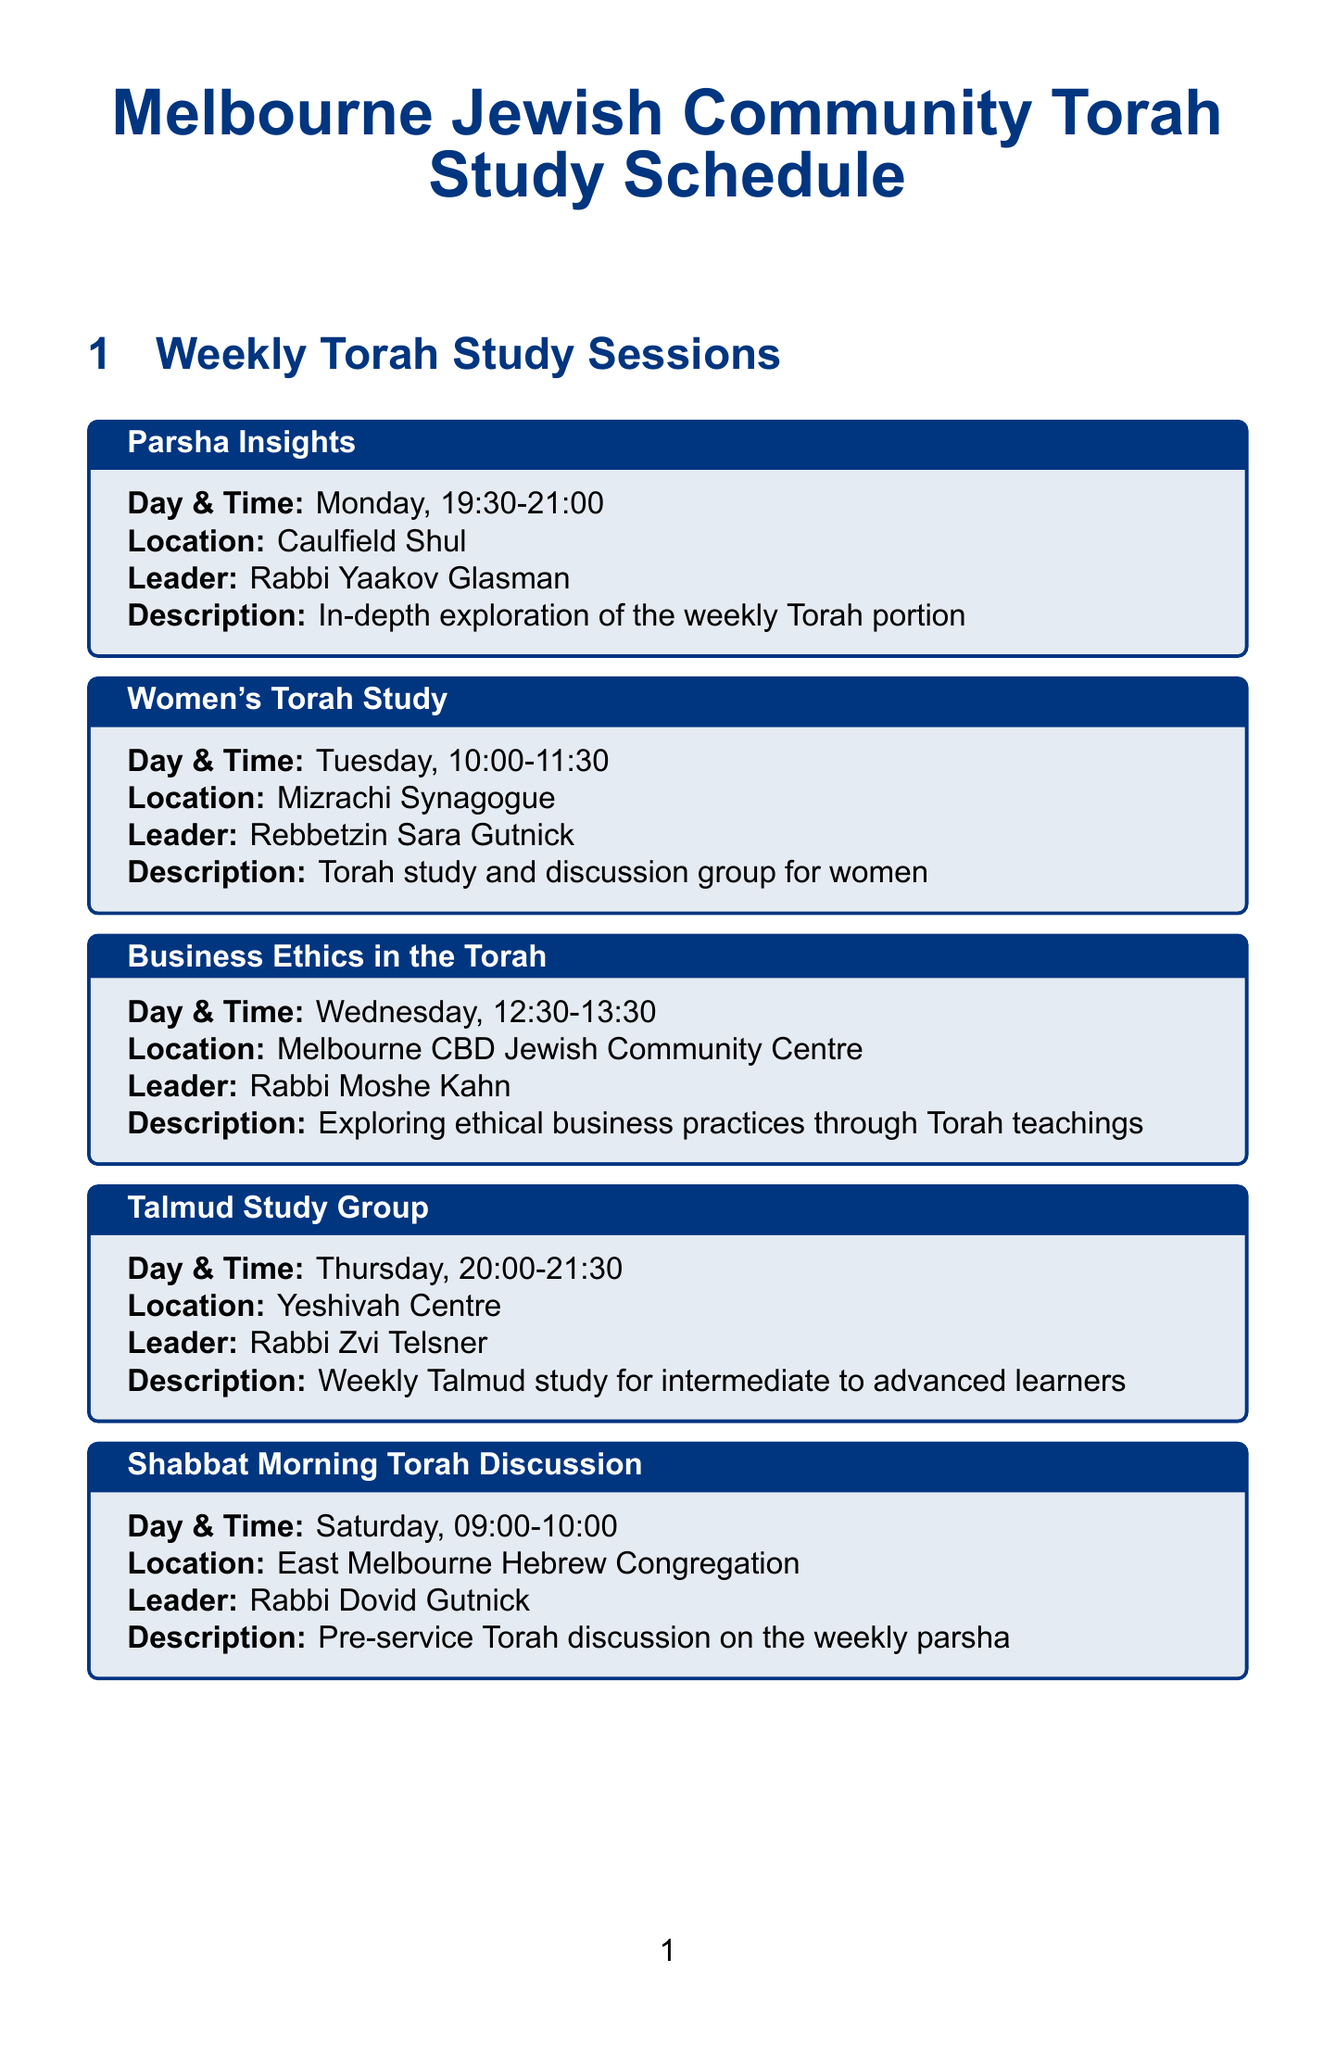What is the day and time for the Women's Torah Study? The Women’s Torah Study session is scheduled for Tuesday at 10:00-11:30.
Answer: Tuesday, 10:00-11:30 Who is the leader of the Business Ethics in the Torah session? The leader of the Business Ethics in the Torah session is Rabbi Moshe Kahn.
Answer: Rabbi Moshe Kahn Where is the Talmud Study Group held? The Talmud Study Group takes place at the Yeshivah Centre.
Answer: Yeshivah Centre What is the purpose of the Monthly Lunch and Learn event? The Monthly Lunch and Learn is a Torah study session with catered kosher lunch.
Answer: Torah study session with catered kosher lunch On which day does the Teen Torah Club meet? The Teen Torah Club meets on Sunday.
Answer: Sunday What is unique about the Torah and Technology Symposium? The Torah and Technology Symposium explores the intersection of Torah wisdom and modern technology.
Answer: Intersection of Torah wisdom and modern technology How often does the Shabbat Morning Torah Discussion occur? The Shabbat Morning Torah Discussion occurs weekly, every Saturday.
Answer: Weekly What are the platforms for the Melbourne Torah Podcast? The Melbourne Torah Podcast can be found on Spotify and Apple Podcasts.
Answer: Spotify and Apple Podcasts 